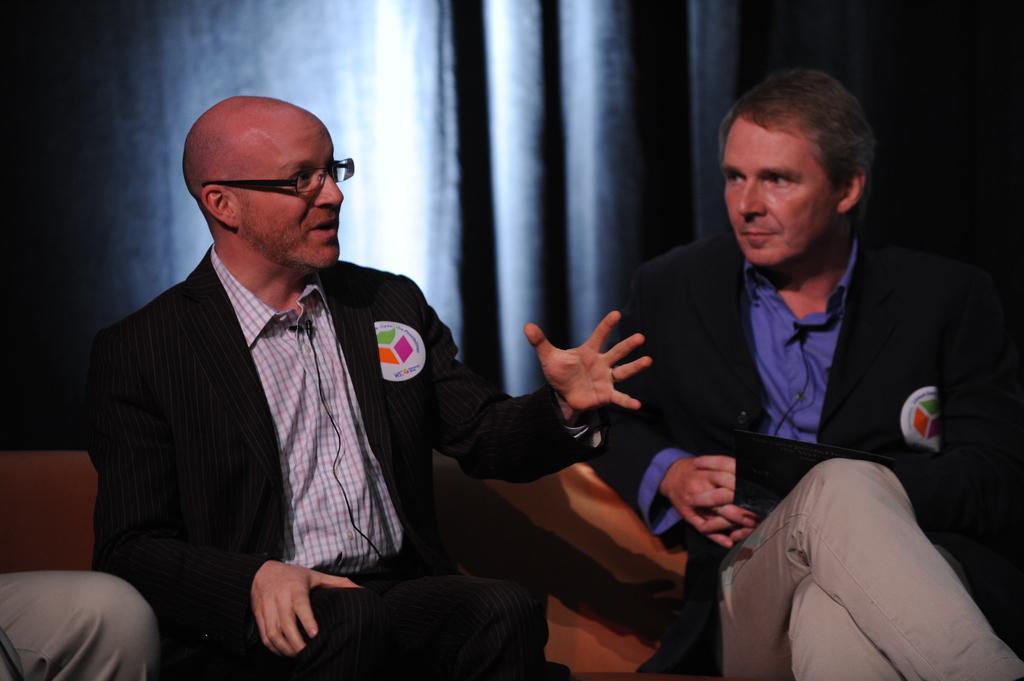Describe this image in one or two sentences. There is one man sitting on a sofa and wearing a black color blazer in the middle of this image. We can see another person is sitting on the right side of this image is also wearing a black color blazer. We can see a leg of another person is on the left side of this image. There is a curtain in the background. 